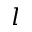<formula> <loc_0><loc_0><loc_500><loc_500>l</formula> 